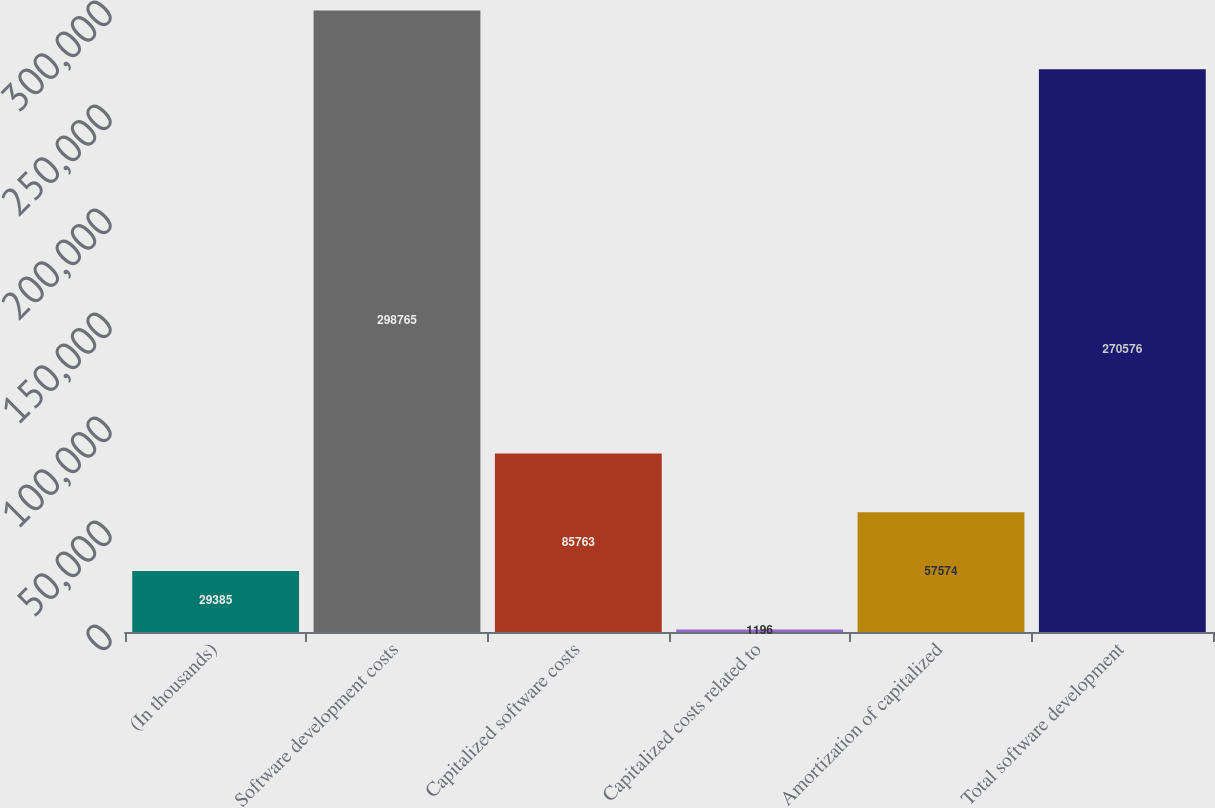<chart> <loc_0><loc_0><loc_500><loc_500><bar_chart><fcel>(In thousands)<fcel>Software development costs<fcel>Capitalized software costs<fcel>Capitalized costs related to<fcel>Amortization of capitalized<fcel>Total software development<nl><fcel>29385<fcel>298765<fcel>85763<fcel>1196<fcel>57574<fcel>270576<nl></chart> 